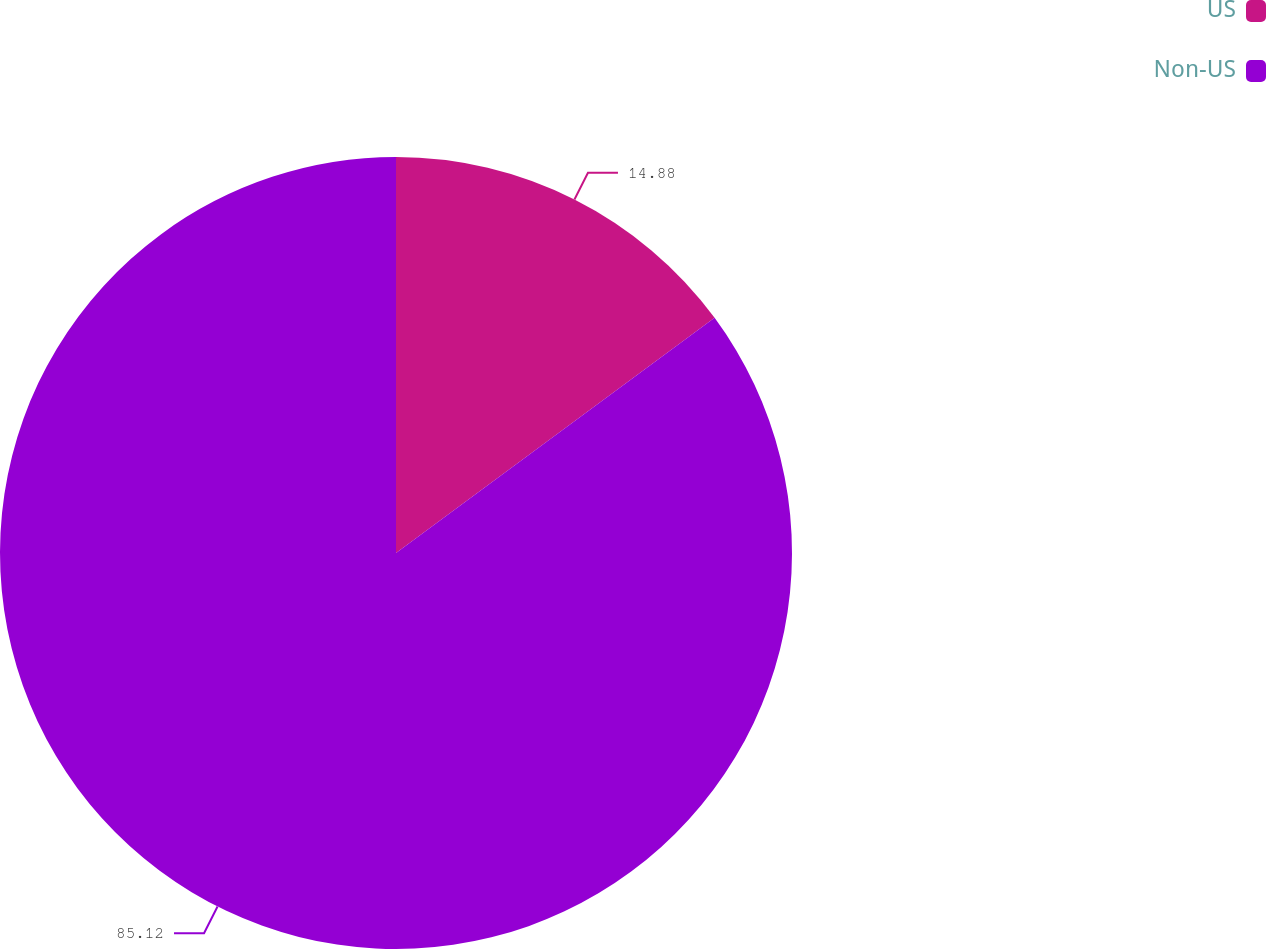Convert chart. <chart><loc_0><loc_0><loc_500><loc_500><pie_chart><fcel>US<fcel>Non-US<nl><fcel>14.88%<fcel>85.12%<nl></chart> 